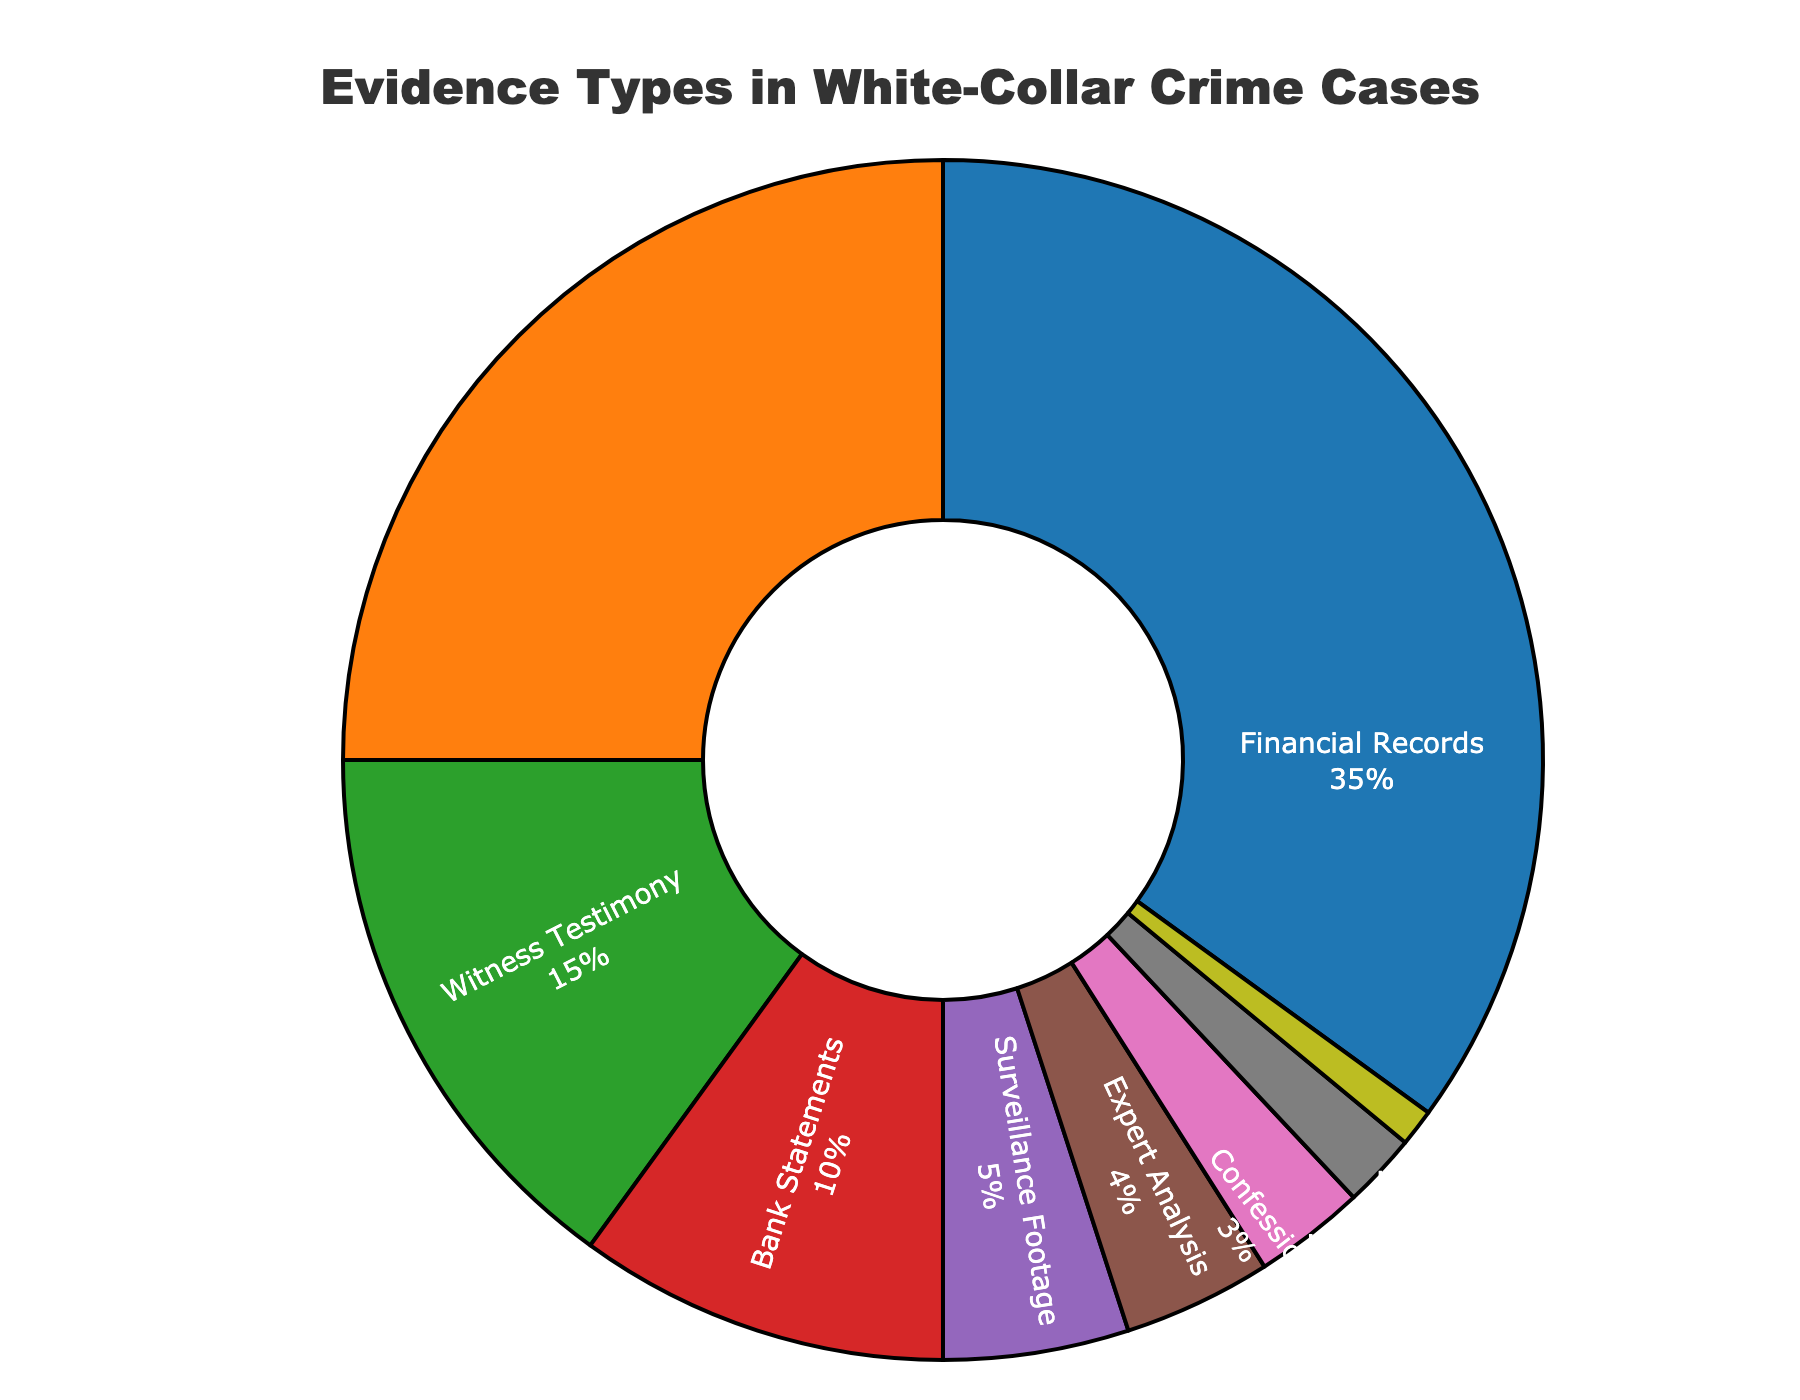Which type of evidence accounts for the highest proportion in white-collar crime cases? The figure shows various types of evidence with their corresponding percentages. The largest segment represents Financial Records at 35%.
Answer: Financial Records What is the combined percentage of Financial Records and Electronic Communications evidence? The figure indicates that Financial Records account for 35% and Electronic Communications for 25%. Adding these together gives 35% + 25% = 60%.
Answer: 60% How much more prevalent are Witness Testimonies compared to Bank Statements? Witness Testimonies are 15% while Bank Statements are 10%. The difference is 15% - 10% = 5%.
Answer: 5% Which types of evidence collectively make up less than 10%? Examining the smaller segments, Expert Analysis (4%), Confessions (3%), Physical Documents (2%), and Digital Forensics (1%) each contribute less than 10%.
Answer: Expert Analysis, Confessions, Physical Documents, Digital Forensics By what percentage does the contribution of Surveillance Footage exceed that of Digital Forensics? Surveillance Footage is 5% and Digital Forensics is 1%. The difference is 5% - 1% = 4%.
Answer: 4% What are the three least common types of evidence? The three smallest segments represent Digital Forensics (1%), Physical Documents (2%), and Confessions (3%).
Answer: Digital Forensics, Physical Documents, Confessions If you combine the percentages of Surveillance Footage and Bank Statements, how does it compare to the percentage of Electronic Communications? Surveillance Footage is 5% and Bank Statements are 10%, together making 5% + 10% = 15%, which is lower than Electronic Communications at 25%.
Answer: Lower What is the percentage difference between the most common and least common types of evidence? Financial Records (35%) is the most common, and Digital Forensics (1%) is the least common. The difference is 35% - 1% = 34%.
Answer: 34% Which type of evidence is represented by the green segment in the figure, and what is its percentage? The green segment corresponds to Witness Testimony, which is 15%.
Answer: Witness Testimony, 15% How does the percentage of Expert Analysis compare to Physical Documents? Expert Analysis is 4% while Physical Documents are 2%. Expert Analysis is twice as much as Physical Documents.
Answer: Twice as much 